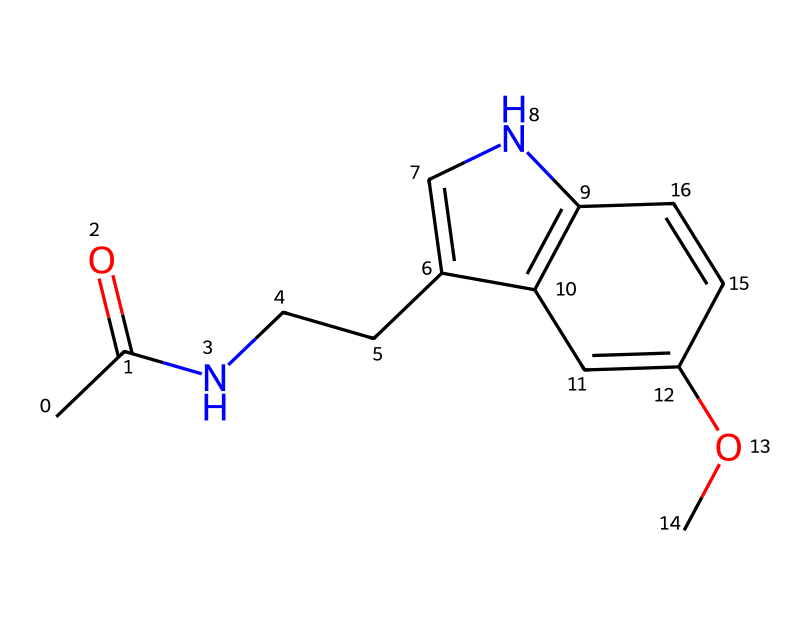How many carbon atoms are in melatonin? To find the number of carbon atoms in the SMILES representation, count each carbon (C) that appears. In this case, there are 11 carbon atoms present as indicated in the structure.
Answer: 11 What is the molecular formula of melatonin? The molecular formula is derived from the total count of each type of atom in the SMILES. It includes 11 carbons (C), 13 hydrogens (H), 1 nitrogen (N), and 2 oxygens (O), yielding the formula C13H16N2O2.
Answer: C13H16N2O2 Which functional groups are present in melatonin? By analyzing the structure, identify the key functional groups. The structure has an amide (due to the carbonyl adjacent to the nitrogen), an ether (C-O-C linkage), and an indole ring system, indicating multiple functionalities.
Answer: amide, ether What type of compound is melatonin? Melatonin is classified as a non-electrolyte because it does not dissociate into ions in solution and is soluble in organic solvents; this classification relies on its molecular structure without ionic components.
Answer: non-electrolyte How many rings are in the melatonin structure? To determine the number of rings, look for closed loops in the structure. In this case, there are two fused aromatic rings, confirming the presence of 2 rings in the compound.
Answer: 2 What type of bonding is primarily present in melatonin? The SMILES notation indicates primarily covalent bonds throughout the structure, as seen with the varied connectivity of carbon, nitrogen, and oxygen atoms, where electron sharing occurs.
Answer: covalent Is melatonin soluble in water? Melatonin is typically poorly soluble in water due to its hydrophobic nature stemming from the aromatic rings; the presence of long carbon chains also contributes to its non-polar characteristics affecting solubility.
Answer: poorly soluble 